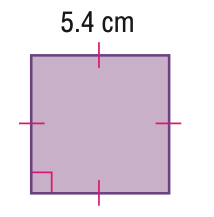Answer the mathemtical geometry problem and directly provide the correct option letter.
Question: Find the area of the parallelogram. Round to the nearest tenth if necessary.
Choices: A: 10.8 B: 21.6 C: 25 D: 29.2 D 